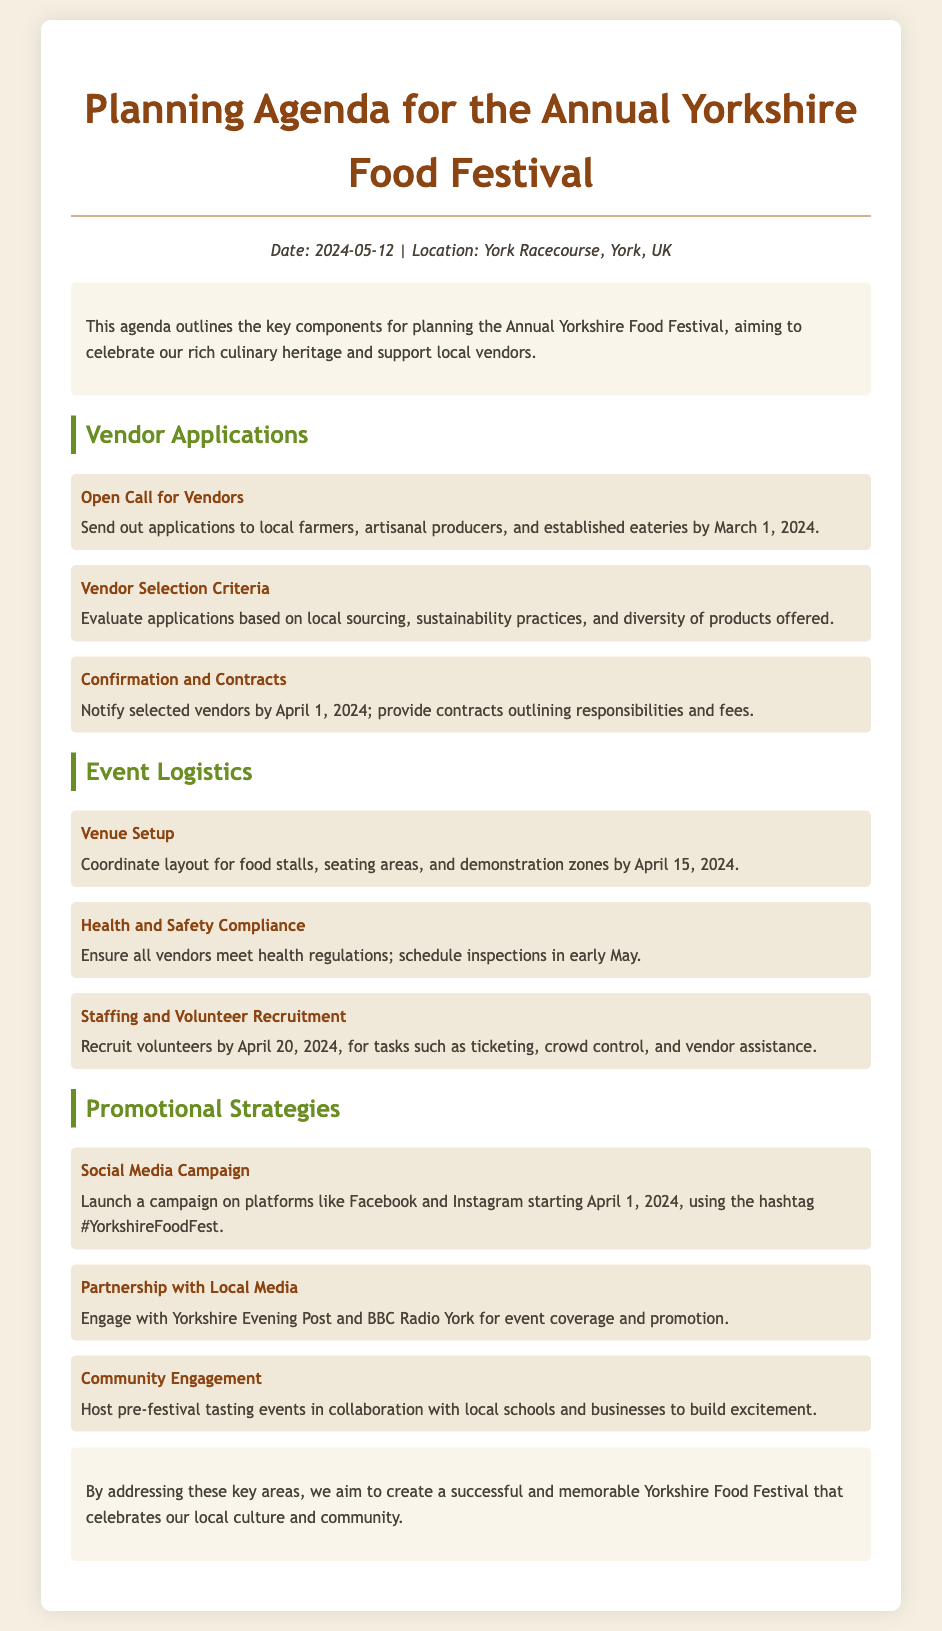What is the date of the Yorkshire Food Festival? The date of the festival is clearly stated in the document as May 12, 2024.
Answer: May 12, 2024 Where is the festival located? The location of the festival is mentioned as the York Racecourse, York, UK.
Answer: York Racecourse, York, UK When is the open call for vendors due? The document specifies that applications should be sent out by March 1, 2024.
Answer: March 1, 2024 What is one criterion for vendor selection? The document outlines that applications will be evaluated based on sustainability practices among other criteria.
Answer: Sustainability practices By when should selected vendors be notified? According to the agenda, selected vendors should be notified by April 1, 2024.
Answer: April 1, 2024 What health regulation activity is scheduled for early May? The document states that inspections to ensure health regulations compliance will take place in early May.
Answer: Inspections What aspect of event promotion begins on April 1, 2024? The document indicates that a social media campaign will launch starting on April 1, 2024.
Answer: Social media campaign With which media outlet is a partnership planned for event promotion? The agenda mentions partnership with Yorkshire Evening Post for event coverage.
Answer: Yorkshire Evening Post What is the aim of the Yorkshire Food Festival, as stated in the conclusion? The conclusion emphasizes that the aim is to create a successful festival that celebrates local culture and community.
Answer: Celebrate local culture and community 